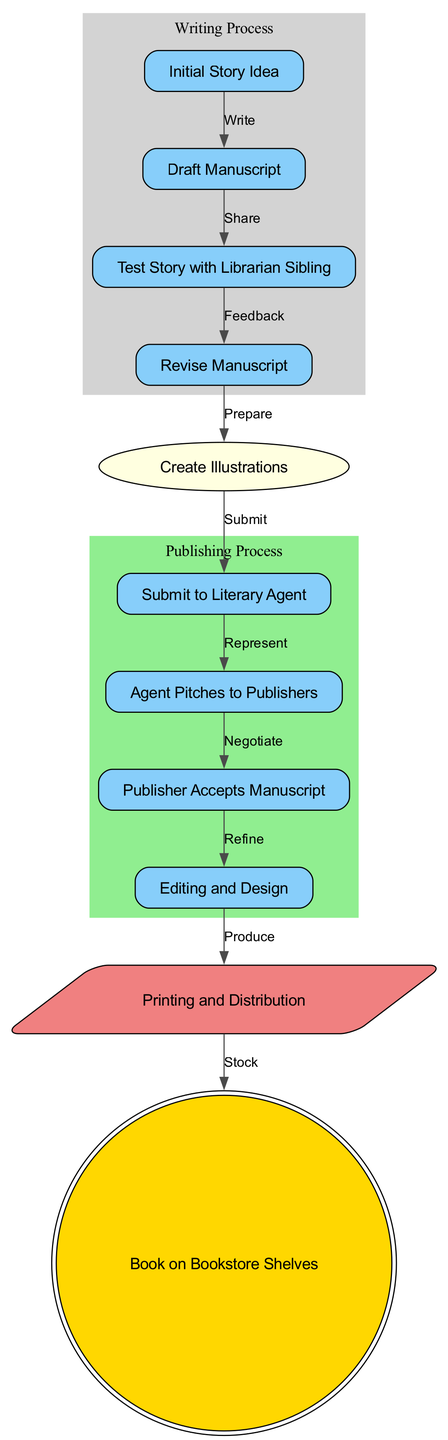What is the first step in the publishing process? The diagram starts with the node labeled "Initial Story Idea," which represents the first step in the publishing process before any writing or drafting occurs.
Answer: Initial Story Idea How many nodes are there in the diagram? By counting all the distinct labeled steps represented in the diagram, there are a total of 11 nodes.
Answer: 11 What happens after the 'Draft Manuscript'? The arrow leading from "Draft Manuscript" points to "Test Story with Librarian Sibling," indicating that the next step involves sharing the draft to receive feedback.
Answer: Test Story with Librarian Sibling Which node comes directly after 'Publisher Accepts Manuscript'? The diagram shows that directly following "Publisher Accepts Manuscript," the next step is "Editing and Design," which focuses on refining the manuscript’s content and layout.
Answer: Editing and Design How many edges are there linking the nodes? There are a total of 10 edges connecting various nodes in the diagram, which illustrates the sequence and flow of actions from one stage to the next in the publishing process.
Answer: 10 In which section does 'Create Illustrations' fall? The node labeled "Create Illustrations" is part of the "Writing Process" section because it deals with preparing the visual components that accompany the text of the book.
Answer: Writing Process What is the final step before the book reaches the shelves? The step before the book is placed on bookstore shelves is "Printing and Distribution," which involves the physical production and delivery to stores.
Answer: Printing and Distribution What relationship does 'Agent Pitches to Publishers' have with 'Submit to Literary Agent'? The diagram shows a directional flow from "Submit to Literary Agent" to "Agent Pitches to Publishers," indicating that the first step involves submission and the second is the agent’s action of promoting the manuscript to potential publishers.
Answer: Represents Which step involves feedback collection? The step where feedback occurs is "Test Story with Librarian Sibling," as it denotes the action of sharing the draft for opinions and suggestions before revisions are made.
Answer: Test Story with Librarian Sibling What color represents the 'Writing Process' section in the diagram? The 'Writing Process' section is filled with light grey, which visually distinguishes it from other sections within the diagram for clarity and organization.
Answer: Light grey 